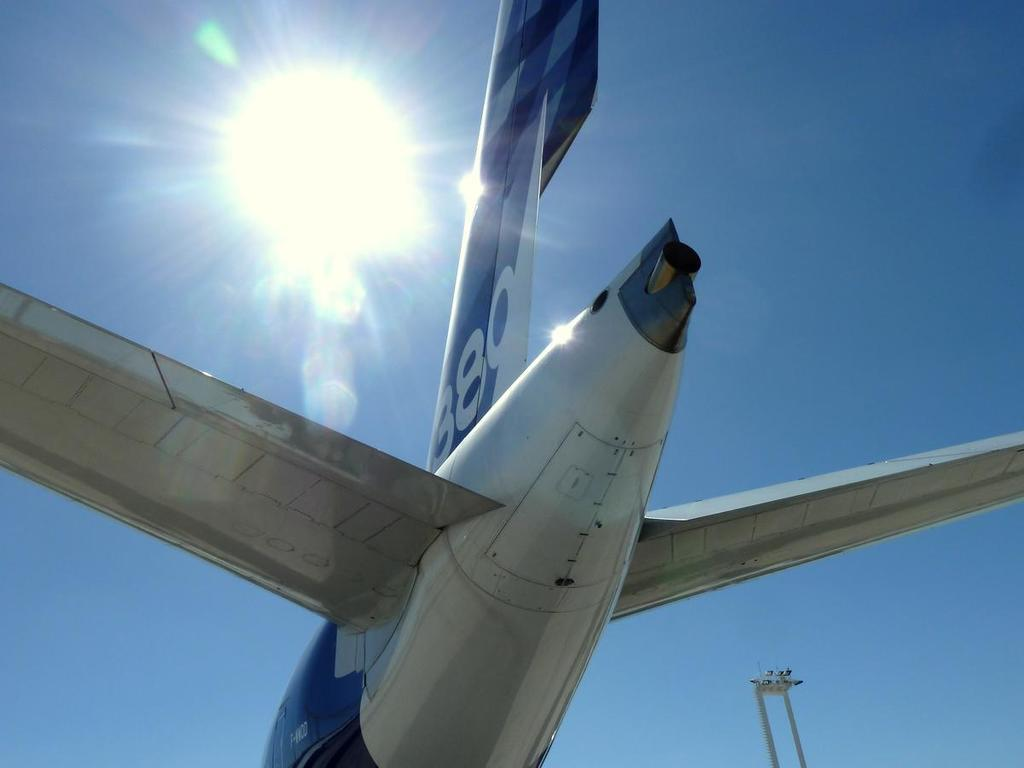<image>
Describe the image concisely. A tail of a airplane with the number 880 is in the foreground with the sun behind it in the sky. 